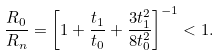<formula> <loc_0><loc_0><loc_500><loc_500>\frac { R _ { 0 } } { R _ { n } } = \left [ 1 + \frac { t _ { 1 } } { t _ { 0 } } + \frac { 3 t _ { 1 } ^ { 2 } } { 8 t _ { 0 } ^ { 2 } } \right ] ^ { - 1 } < 1 .</formula> 